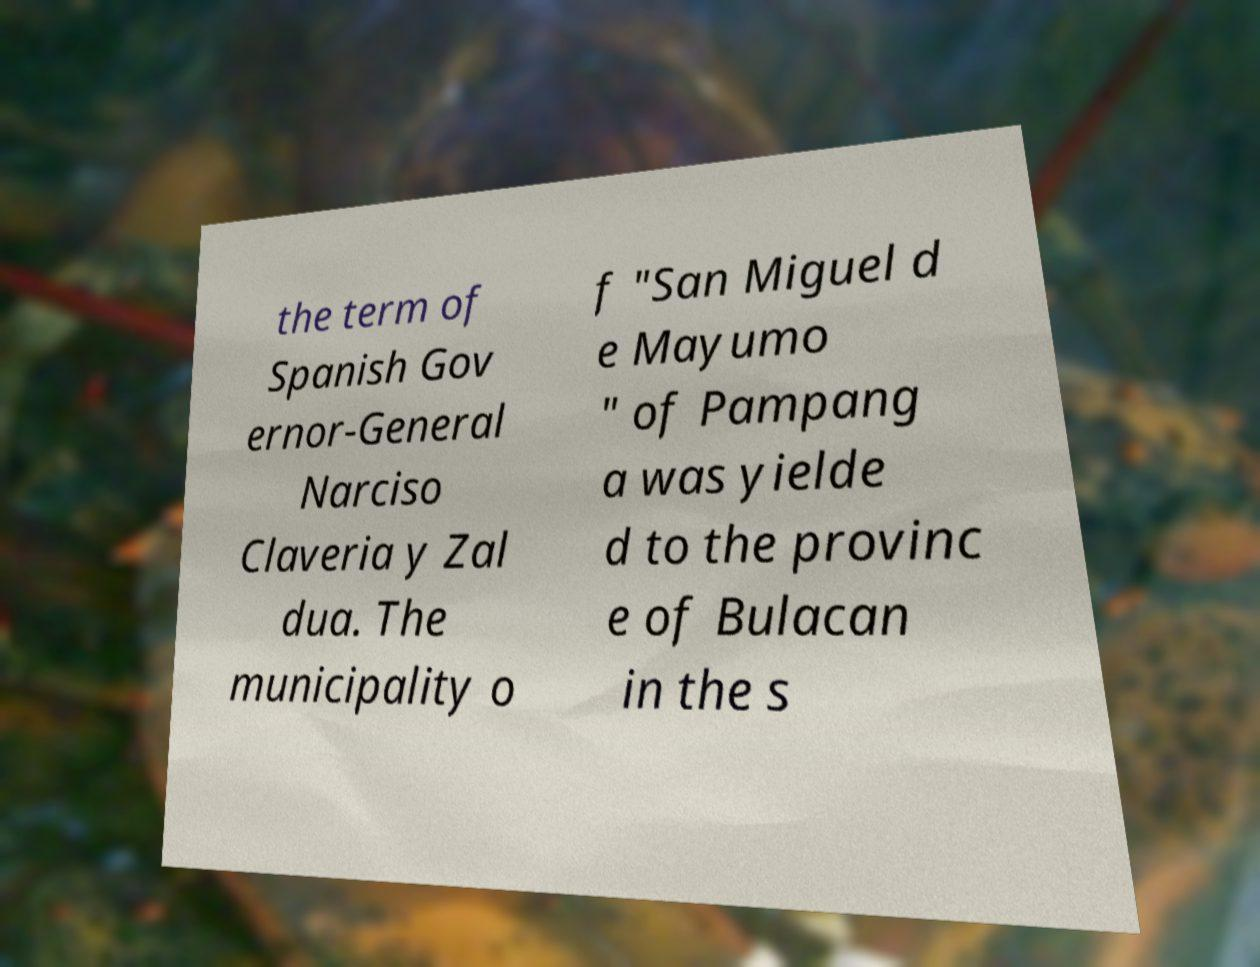There's text embedded in this image that I need extracted. Can you transcribe it verbatim? the term of Spanish Gov ernor-General Narciso Claveria y Zal dua. The municipality o f "San Miguel d e Mayumo " of Pampang a was yielde d to the provinc e of Bulacan in the s 